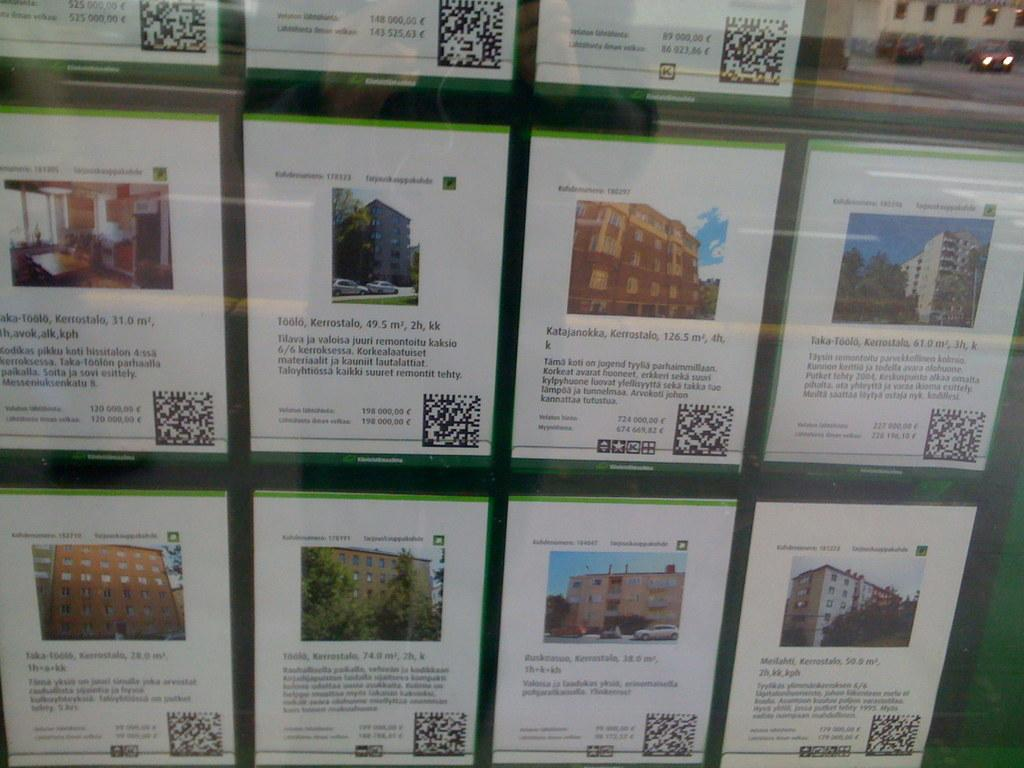Provide a one-sentence caption for the provided image. Small information signs feature facts about places like Kerrostalo and Katajanokka. 